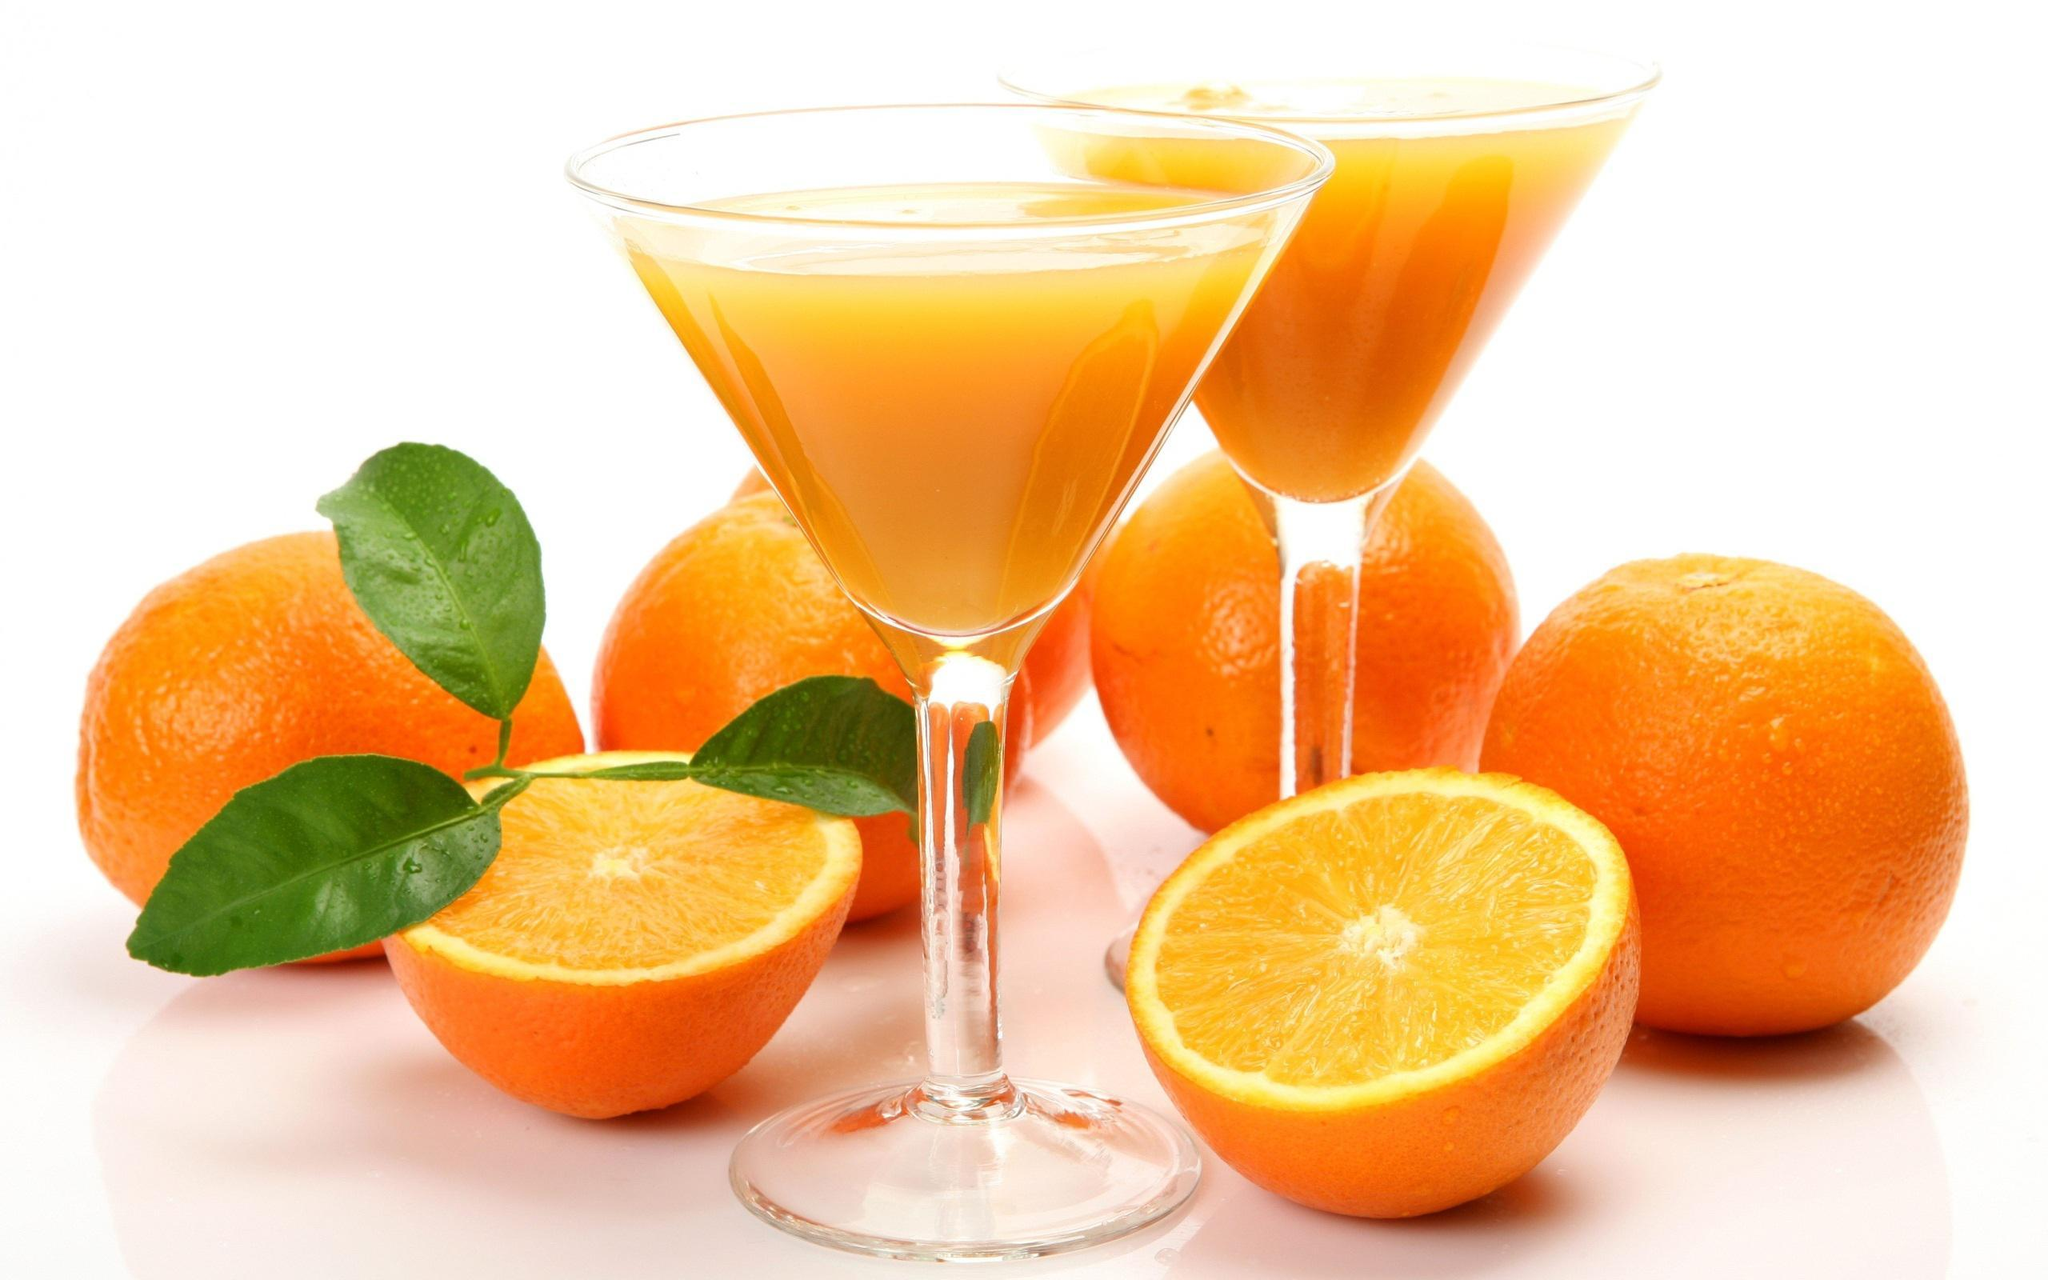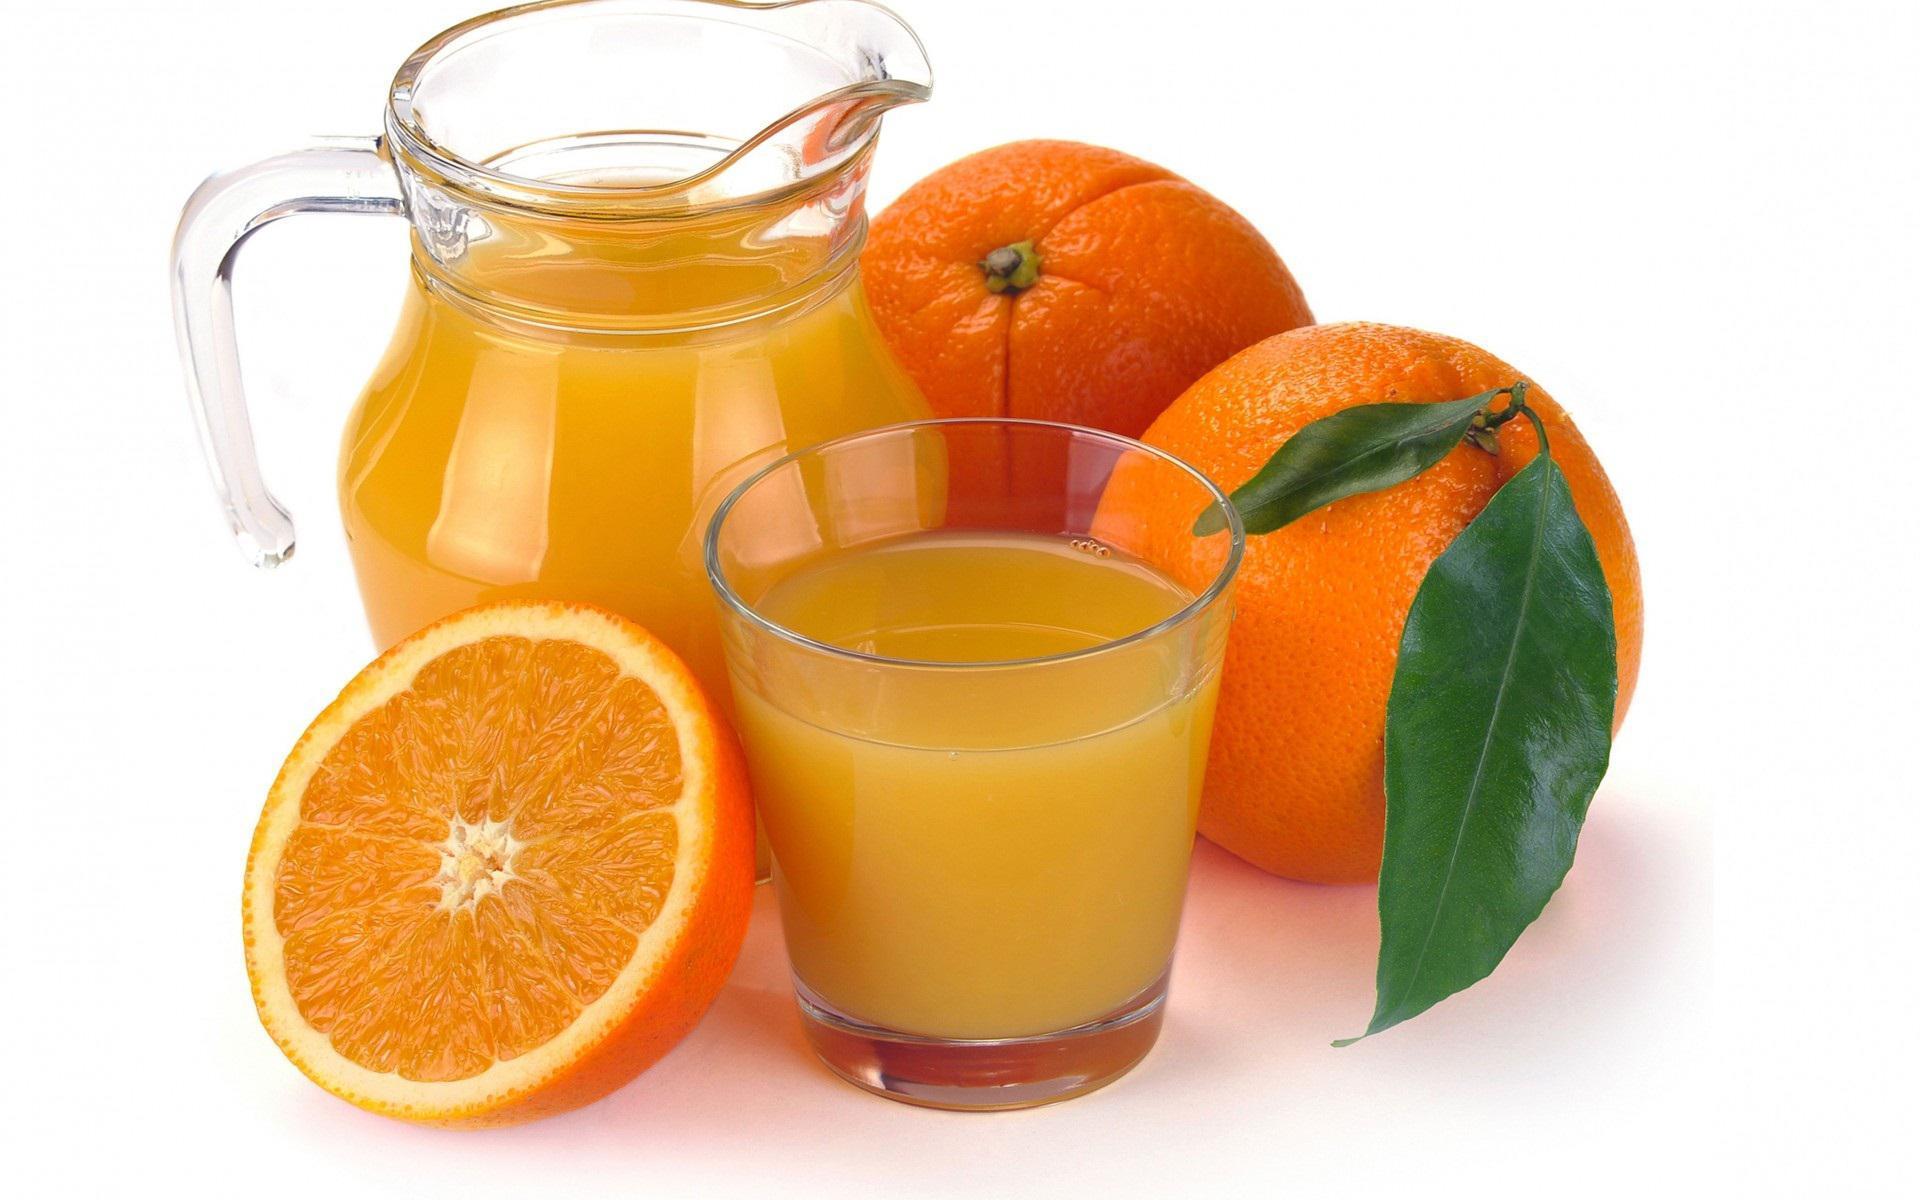The first image is the image on the left, the second image is the image on the right. Assess this claim about the two images: "Each image includes one glass containing an orange beverage and one wedge of orange.". Correct or not? Answer yes or no. No. The first image is the image on the left, the second image is the image on the right. Evaluate the accuracy of this statement regarding the images: "At least one of the oranges still has its stem and leaves attached to it.". Is it true? Answer yes or no. Yes. 